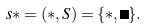Convert formula to latex. <formula><loc_0><loc_0><loc_500><loc_500>s \ast = ( \ast , S ) = \{ \ast , \Omega \} .</formula> 